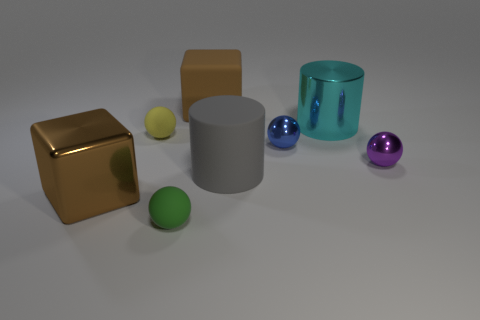Which objects in the image have reflective surfaces? The golden cube and the colored spheres have reflective surfaces that create specular highlights, making them stand out as shiny objects. 